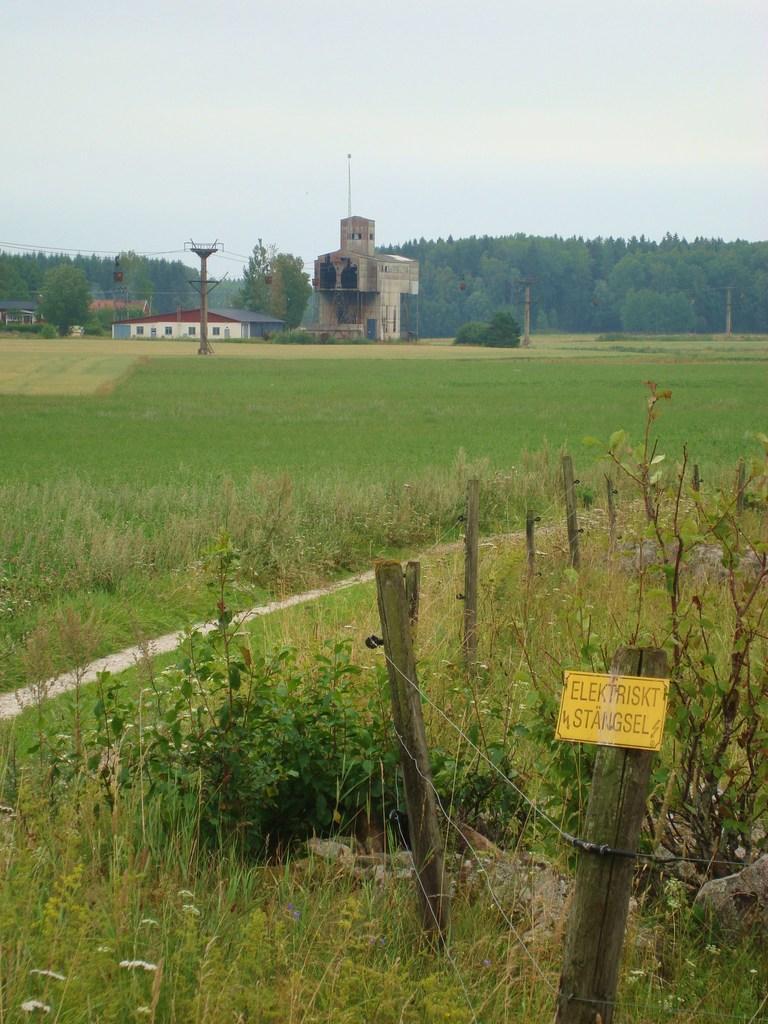Can you describe this image briefly? In the front of the image there are plants, grass, wooden sticks and a board. Board is on the wooden stick, something is written on the board. In the background of the image there are buildings, plants, poles, trees and the sky. Land is covered with grass. 